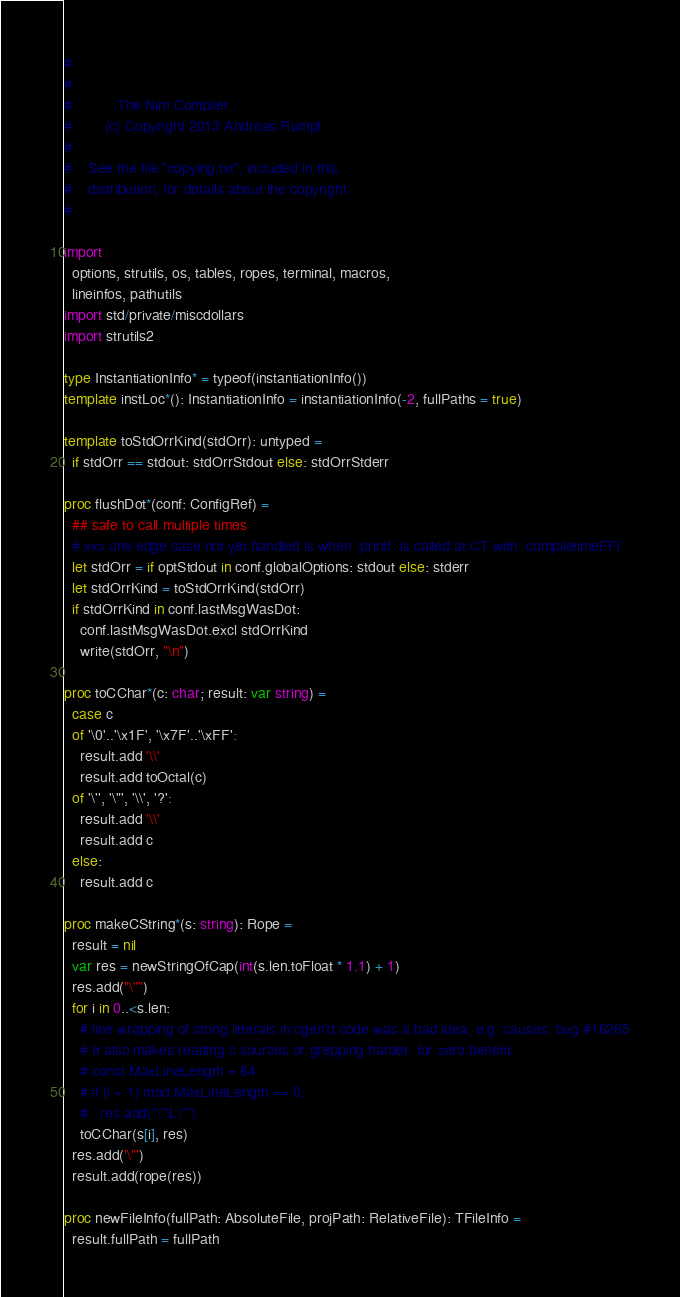Convert code to text. <code><loc_0><loc_0><loc_500><loc_500><_Nim_>#
#
#           The Nim Compiler
#        (c) Copyright 2013 Andreas Rumpf
#
#    See the file "copying.txt", included in this
#    distribution, for details about the copyright.
#

import
  options, strutils, os, tables, ropes, terminal, macros,
  lineinfos, pathutils
import std/private/miscdollars
import strutils2

type InstantiationInfo* = typeof(instantiationInfo())
template instLoc*(): InstantiationInfo = instantiationInfo(-2, fullPaths = true)

template toStdOrrKind(stdOrr): untyped =
  if stdOrr == stdout: stdOrrStdout else: stdOrrStderr

proc flushDot*(conf: ConfigRef) =
  ## safe to call multiple times
  # xxx one edge case not yet handled is when `printf` is called at CT with `compiletimeFFI`.
  let stdOrr = if optStdout in conf.globalOptions: stdout else: stderr
  let stdOrrKind = toStdOrrKind(stdOrr)
  if stdOrrKind in conf.lastMsgWasDot:
    conf.lastMsgWasDot.excl stdOrrKind
    write(stdOrr, "\n")

proc toCChar*(c: char; result: var string) =
  case c
  of '\0'..'\x1F', '\x7F'..'\xFF':
    result.add '\\'
    result.add toOctal(c)
  of '\'', '\"', '\\', '?':
    result.add '\\'
    result.add c
  else:
    result.add c

proc makeCString*(s: string): Rope =
  result = nil
  var res = newStringOfCap(int(s.len.toFloat * 1.1) + 1)
  res.add("\"")
  for i in 0..<s.len:
    # line wrapping of string litterals in cgen'd code was a bad idea, e.g. causes: bug #16265
    # It also makes reading c sources or grepping harder, for zero benefit.
    # const MaxLineLength = 64
    # if (i + 1) mod MaxLineLength == 0:
    #   res.add("\"\L\"")
    toCChar(s[i], res)
  res.add('\"')
  result.add(rope(res))

proc newFileInfo(fullPath: AbsoluteFile, projPath: RelativeFile): TFileInfo =
  result.fullPath = fullPath</code> 